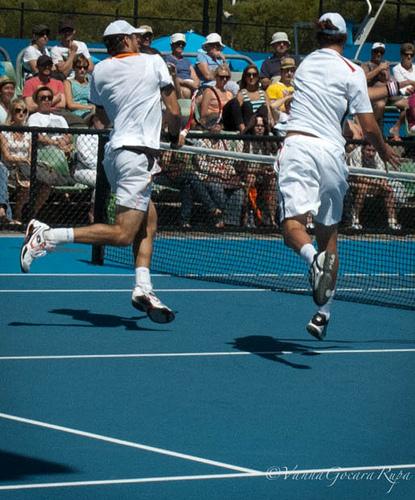Are the stands full?
Give a very brief answer. Yes. What color is the court?
Keep it brief. Blue. How does the man wear his cap?
Quick response, please. Forward. Is the sun shining during this game?
Quick response, please. Yes. How many people total are probably playing this game?
Concise answer only. 4. 